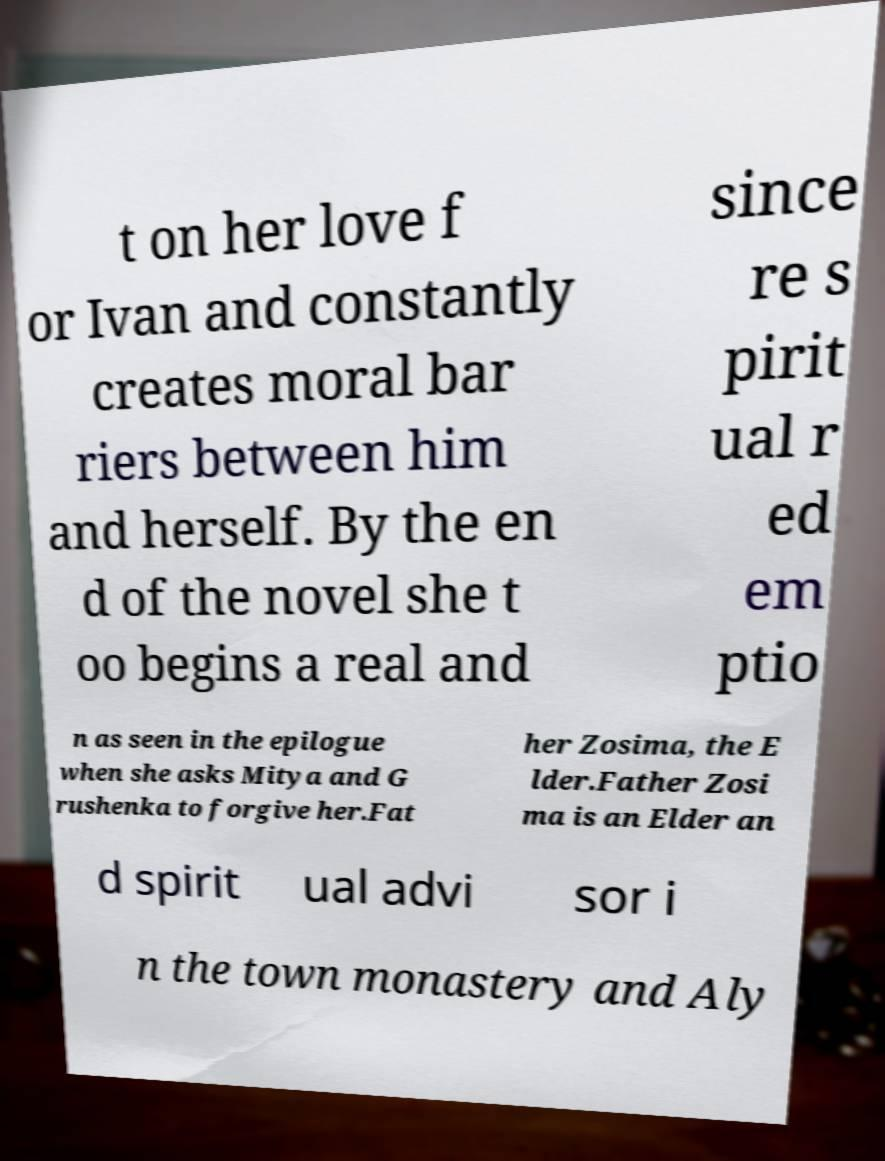Can you accurately transcribe the text from the provided image for me? t on her love f or Ivan and constantly creates moral bar riers between him and herself. By the en d of the novel she t oo begins a real and since re s pirit ual r ed em ptio n as seen in the epilogue when she asks Mitya and G rushenka to forgive her.Fat her Zosima, the E lder.Father Zosi ma is an Elder an d spirit ual advi sor i n the town monastery and Aly 